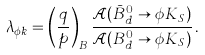Convert formula to latex. <formula><loc_0><loc_0><loc_500><loc_500>\lambda _ { \phi k } = \left ( \frac { q } { p } \right ) _ { B } \frac { \mathcal { A } ( \bar { B } ^ { 0 } _ { d } \rightarrow \phi K _ { S } ) } { \mathcal { A } ( B ^ { 0 } _ { d } \rightarrow \phi K _ { S } ) } \, .</formula> 